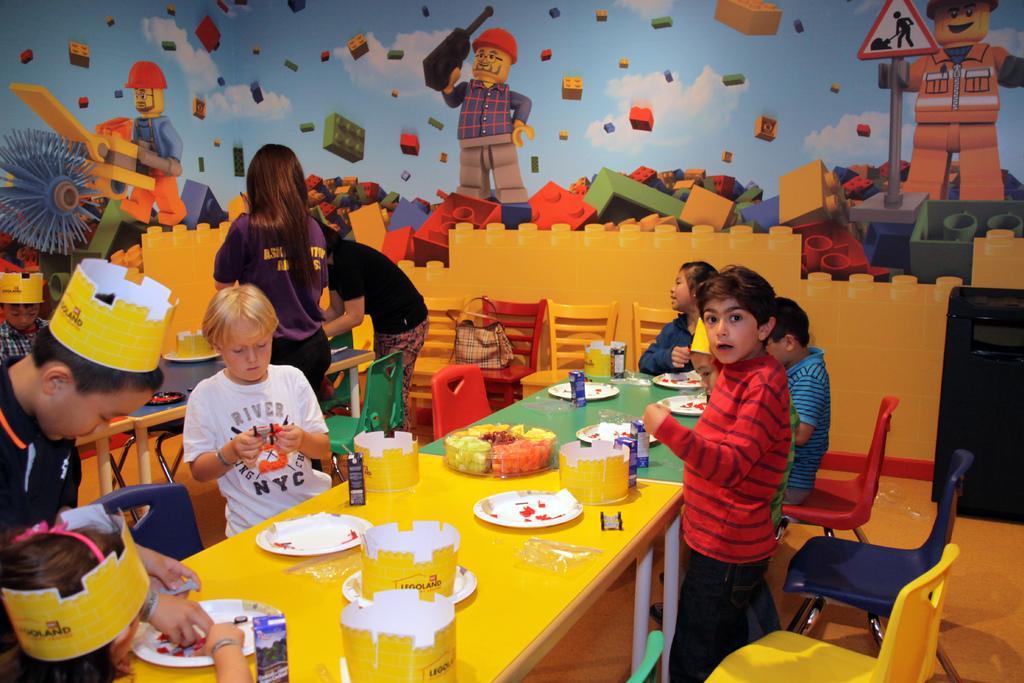In one or two sentences, can you explain what this image depicts? In this image I see number of children and I see 2 persons over here and I see the tables on which there are plates and other things and I see the chairs which are colorful and I see a dark blue thing over here. In the background I see the wall on which there is art. 